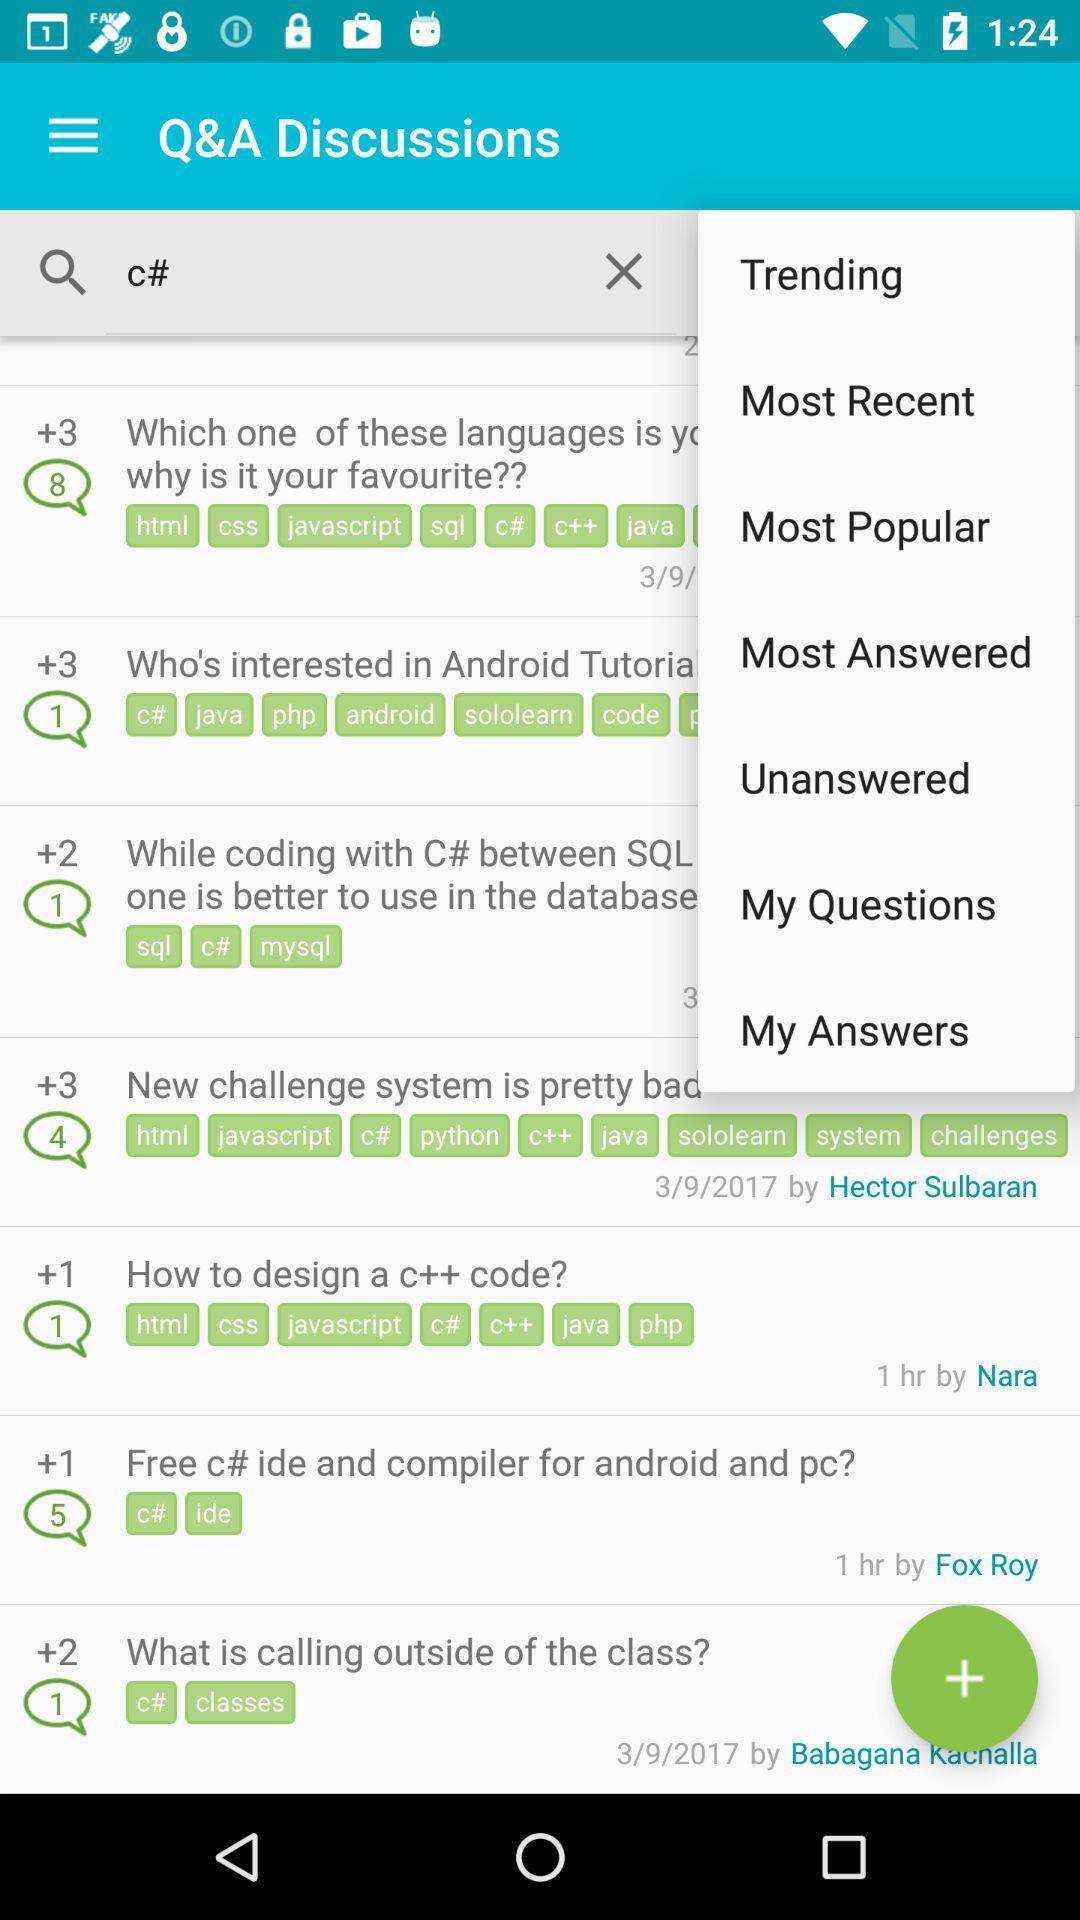What's the total number of answers in the chat box for "How to design a C++ code?"? The total number of answers is 1. 